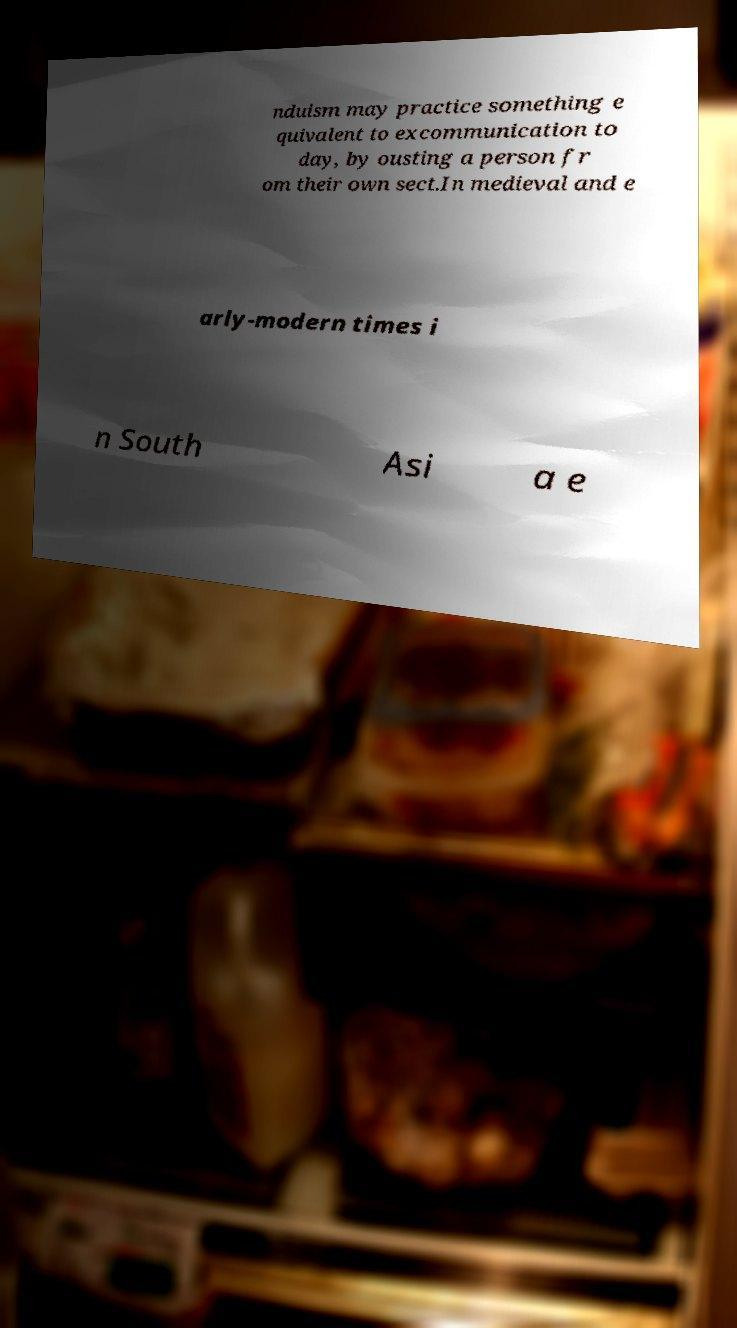Could you assist in decoding the text presented in this image and type it out clearly? nduism may practice something e quivalent to excommunication to day, by ousting a person fr om their own sect.In medieval and e arly-modern times i n South Asi a e 